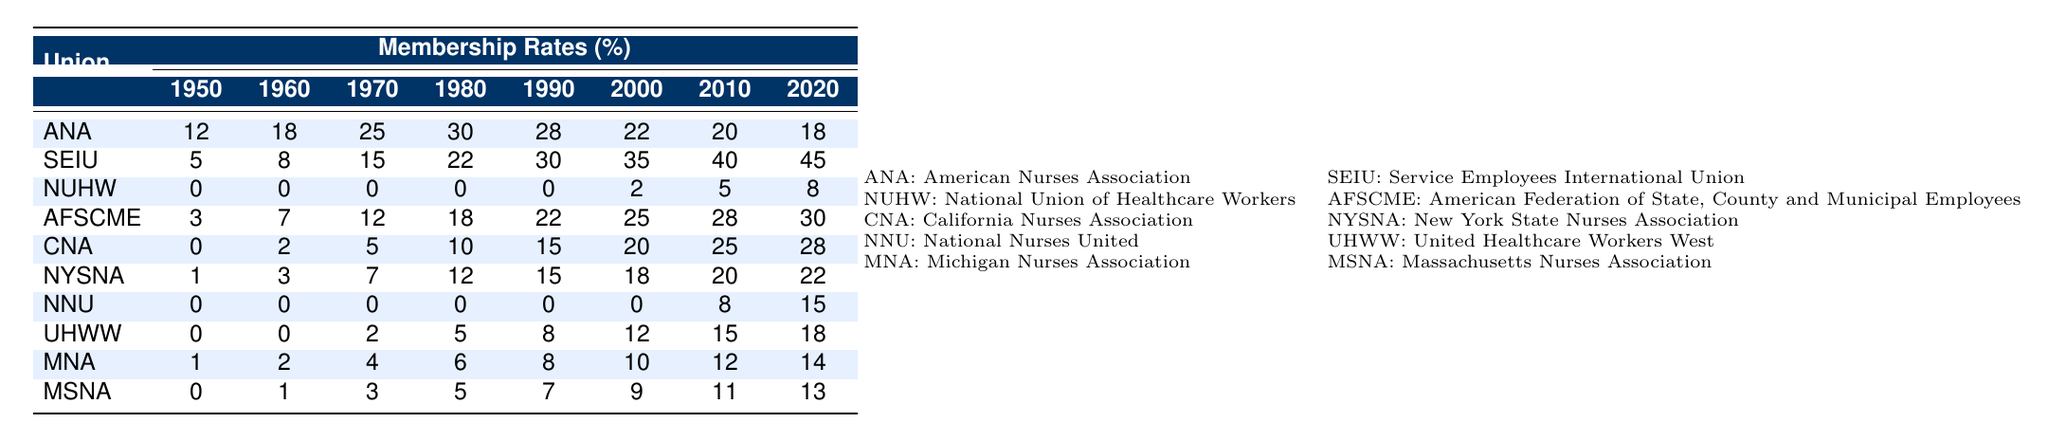What was the membership rate of the Service Employees International Union in 1980? The table shows that the membership rate for SEIU in 1980 is 22%.
Answer: 22% Which union had the highest membership rate in 2020? Looking at the last column (2020), the Service Employees International Union has the highest membership rate of 45%.
Answer: 45% What was the change in membership rate for the American Nurses Association from 1990 to 2000? The membership rate for ANA in 1990 was 28% and in 2000 it was 22%. The change is calculated as 22% - 28% = -6%.
Answer: -6% Did the National Union of Healthcare Workers exist in the table data prior to 2000? The table shows that NUHW had a membership rate of 0% for the years 1950, 1960, 1970, and 1980, indicating it did not exist in those years.
Answer: Yes What is the average membership rate for the California Nurses Association from 1950 to 2020? The membership rates for CNA over the years are 0, 2, 5, 10, 15, 20, 25, and 28. The sum is 0 + 2 + 5 + 10 + 15 + 20 + 25 + 28 = 105, and there are 8 data points, so the average is 105/8 = 13.125.
Answer: 13.125 In which decade did the National Nurses United first have a non-zero membership rate? The first non-zero membership rate for NNU appears in 2010, where it is recorded at 8%. This indicates that it became relevant starting in that decade.
Answer: 2010 What is the total membership rate for the Massachusetts Nurses Association over the entire period? The membership rates for MSNA from 1950 to 2020 are 0, 1, 3, 5, 7, 9, 11, and 13. Adding these yields 0 + 1 + 3 + 5 + 7 + 9 + 11 + 13 = 49.
Answer: 49 By how much did the membership rate of the Michigan Nurses Association increase from 2000 to 2020? In 2000, MNA had a membership rate of 10% and in 2020 it is 14%. Thus, the increase is 14% - 10% = 4%.
Answer: 4% Was the overall trend in membership rates for the American Nurses Association from 1950 to 2020 upward or downward? The membership rates for ANA declined from 30% in 1980 to 18% in 2020, signifying an overall downward trend after a peak.
Answer: Downward What is the percentage difference in membership rates between the Service Employees International Union and the American Nurses Association in 2010? In 2010, SEIU had a membership rate of 40% and ANA had 20%. The difference is 40% - 20% = 20%.
Answer: 20% 